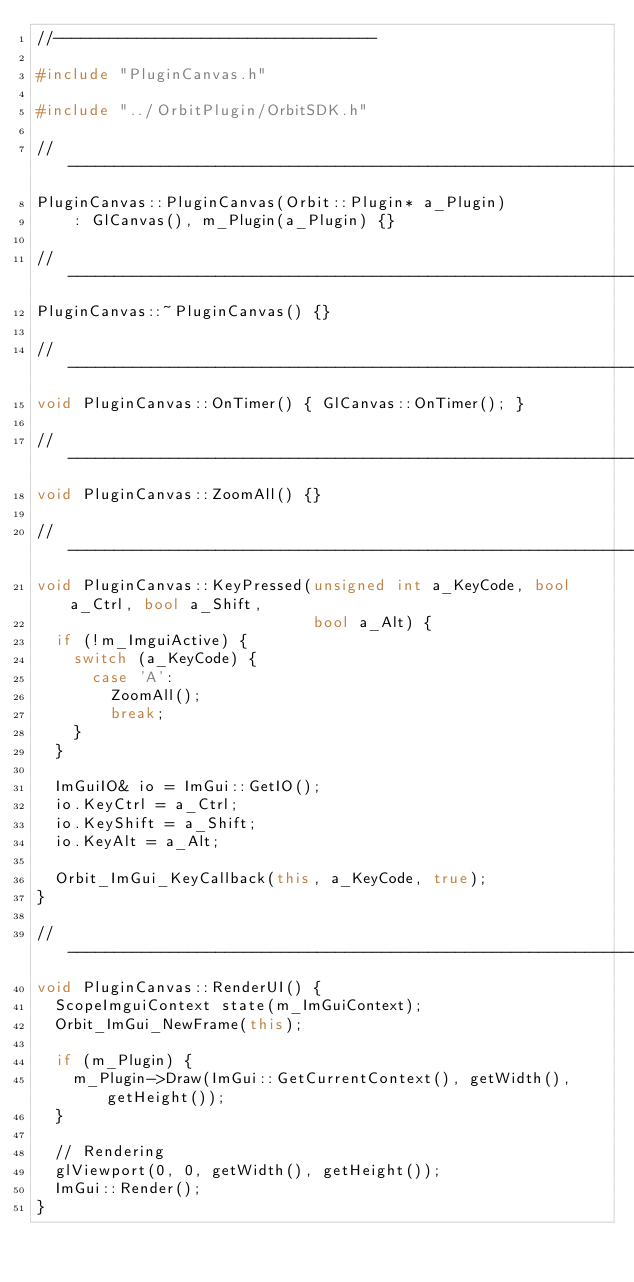<code> <loc_0><loc_0><loc_500><loc_500><_C++_>//-----------------------------------

#include "PluginCanvas.h"

#include "../OrbitPlugin/OrbitSDK.h"

//-----------------------------------------------------------------------------
PluginCanvas::PluginCanvas(Orbit::Plugin* a_Plugin)
    : GlCanvas(), m_Plugin(a_Plugin) {}

//-----------------------------------------------------------------------------
PluginCanvas::~PluginCanvas() {}

//-----------------------------------------------------------------------------
void PluginCanvas::OnTimer() { GlCanvas::OnTimer(); }

//-----------------------------------------------------------------------------
void PluginCanvas::ZoomAll() {}

//-----------------------------------------------------------------------------
void PluginCanvas::KeyPressed(unsigned int a_KeyCode, bool a_Ctrl, bool a_Shift,
                              bool a_Alt) {
  if (!m_ImguiActive) {
    switch (a_KeyCode) {
      case 'A':
        ZoomAll();
        break;
    }
  }

  ImGuiIO& io = ImGui::GetIO();
  io.KeyCtrl = a_Ctrl;
  io.KeyShift = a_Shift;
  io.KeyAlt = a_Alt;

  Orbit_ImGui_KeyCallback(this, a_KeyCode, true);
}

//-----------------------------------------------------------------------------
void PluginCanvas::RenderUI() {
  ScopeImguiContext state(m_ImGuiContext);
  Orbit_ImGui_NewFrame(this);

  if (m_Plugin) {
    m_Plugin->Draw(ImGui::GetCurrentContext(), getWidth(), getHeight());
  }

  // Rendering
  glViewport(0, 0, getWidth(), getHeight());
  ImGui::Render();
}</code> 